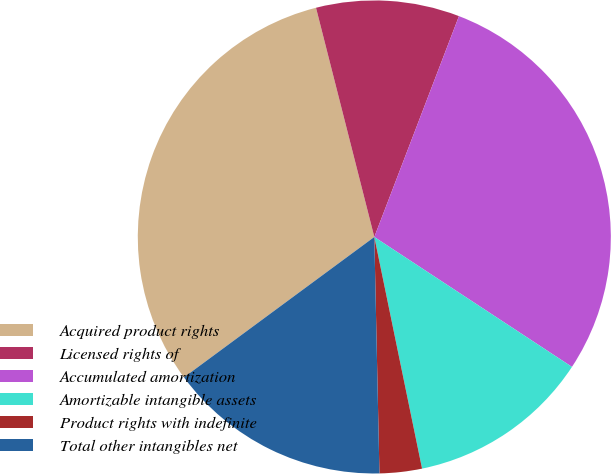Convert chart to OTSL. <chart><loc_0><loc_0><loc_500><loc_500><pie_chart><fcel>Acquired product rights<fcel>Licensed rights of<fcel>Accumulated amortization<fcel>Amortizable intangible assets<fcel>Product rights with indefinite<fcel>Total other intangibles net<nl><fcel>31.15%<fcel>9.79%<fcel>28.43%<fcel>12.51%<fcel>2.89%<fcel>15.23%<nl></chart> 